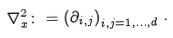Convert formula to latex. <formula><loc_0><loc_0><loc_500><loc_500>\nabla _ { x } ^ { 2 } \colon = \left ( \partial _ { i , j } \right ) _ { i , j = 1 , \dots , d } \, .</formula> 